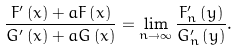Convert formula to latex. <formula><loc_0><loc_0><loc_500><loc_500>\frac { F ^ { \prime } \left ( x \right ) + a F \left ( x \right ) } { G ^ { \prime } \left ( x \right ) + a G \left ( x \right ) } = \lim _ { n \rightarrow \infty } \frac { F _ { n } ^ { \prime } \left ( y \right ) } { G _ { n } ^ { \prime } \left ( y \right ) } .</formula> 